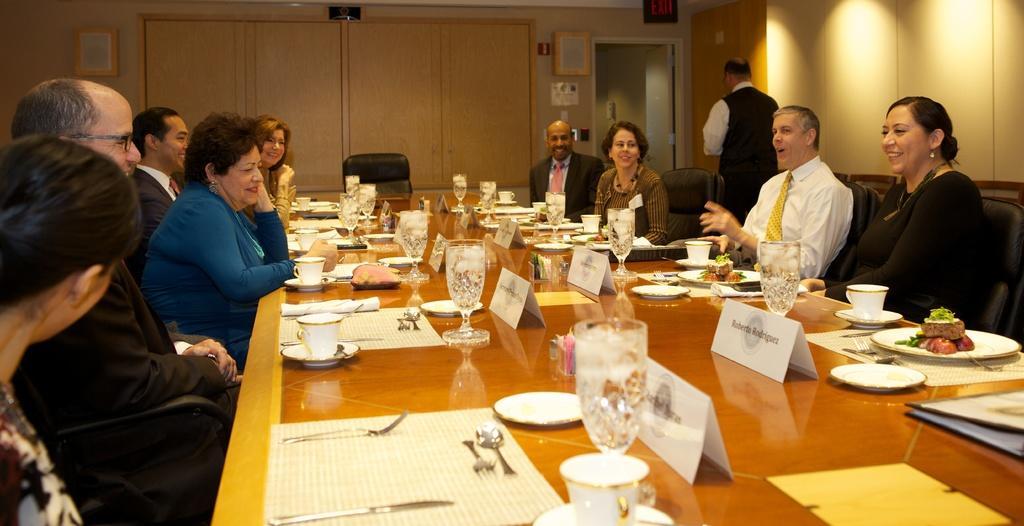Describe this image in one or two sentences. As we can see in the image there is a yellow color wall, door, switch board, few people sitting on chairs and there is a table. On table there is a mat, fork, knife, spoon, plates, glasses, cup, saucer and tissues. 